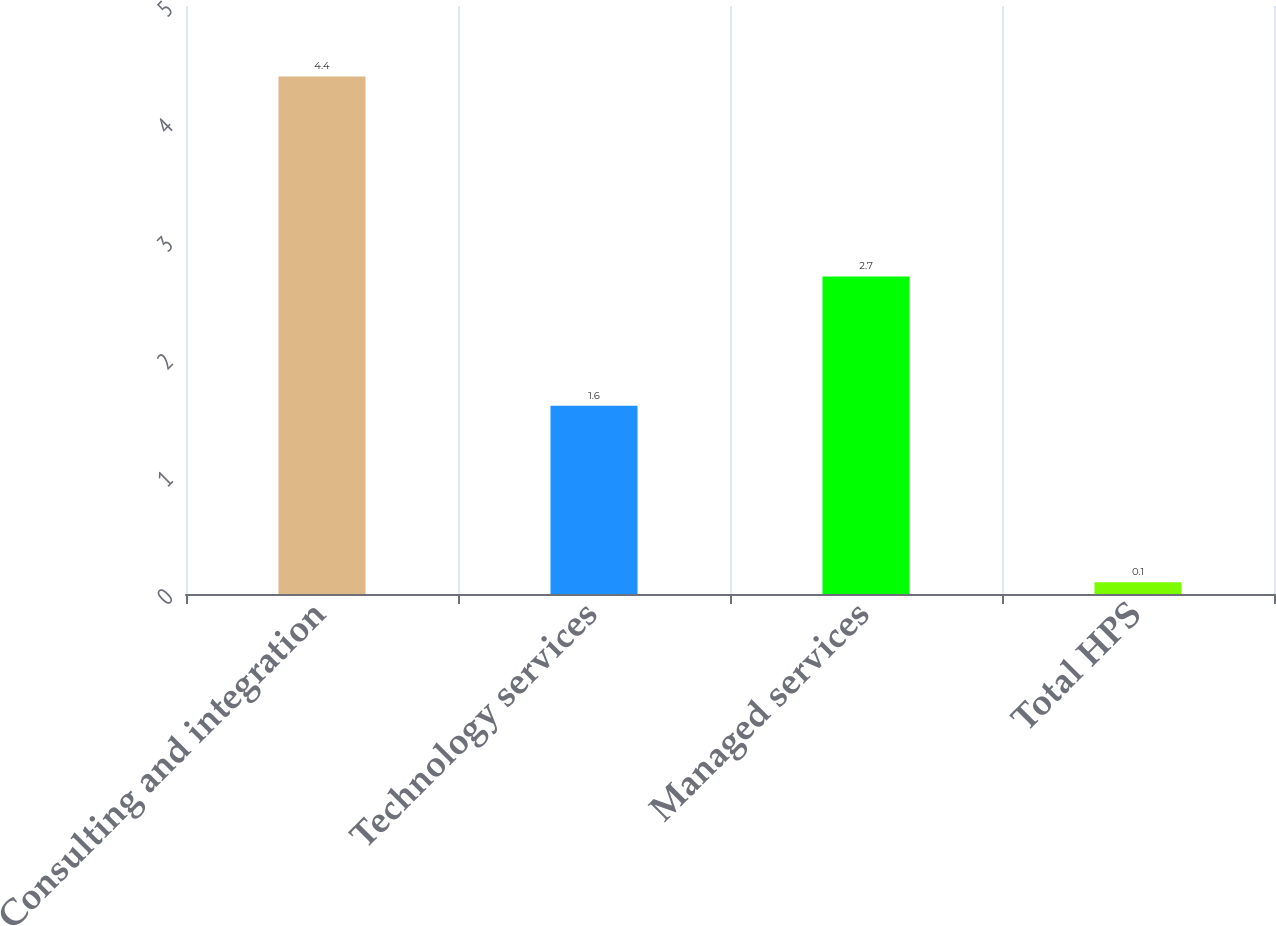Convert chart to OTSL. <chart><loc_0><loc_0><loc_500><loc_500><bar_chart><fcel>Consulting and integration<fcel>Technology services<fcel>Managed services<fcel>Total HPS<nl><fcel>4.4<fcel>1.6<fcel>2.7<fcel>0.1<nl></chart> 